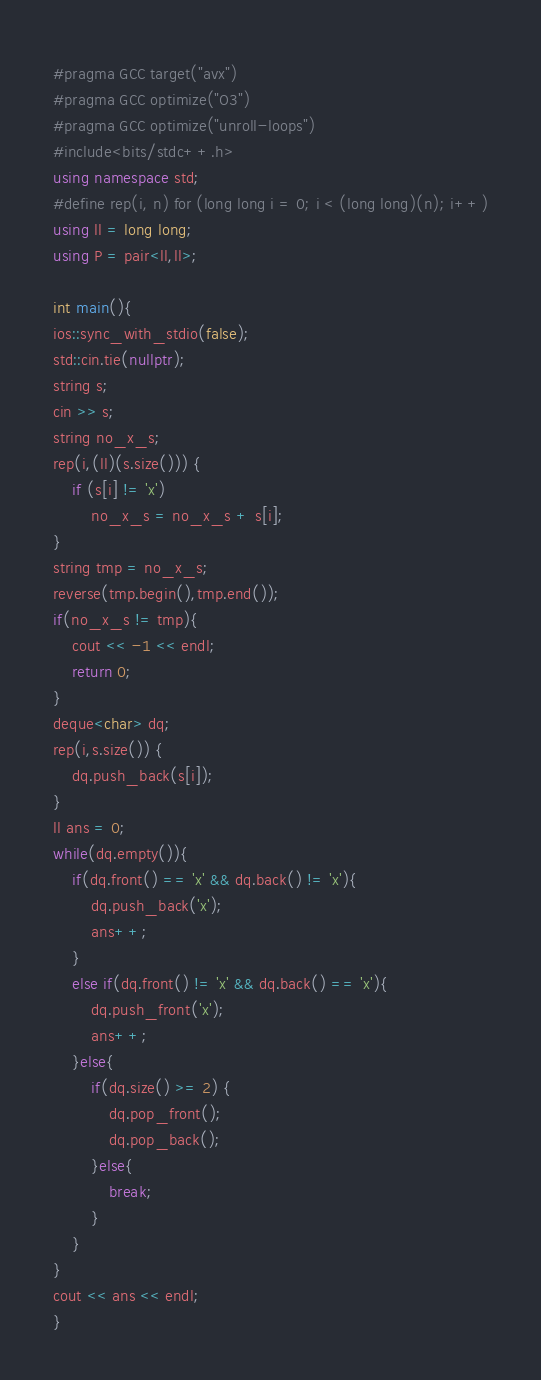<code> <loc_0><loc_0><loc_500><loc_500><_C++_>#pragma GCC target("avx")
#pragma GCC optimize("O3")
#pragma GCC optimize("unroll-loops")
#include<bits/stdc++.h>
using namespace std;
#define rep(i, n) for (long long i = 0; i < (long long)(n); i++)
using ll = long long;
using P = pair<ll,ll>;

int main(){
ios::sync_with_stdio(false);
std::cin.tie(nullptr);
string s;
cin >> s;
string no_x_s;
rep(i,(ll)(s.size())) {
    if (s[i] != 'x')
        no_x_s = no_x_s + s[i];
}
string tmp = no_x_s;
reverse(tmp.begin(),tmp.end());
if(no_x_s != tmp){
    cout << -1 << endl;
    return 0;
}
deque<char> dq;
rep(i,s.size()) {
    dq.push_back(s[i]);
}
ll ans = 0;
while(dq.empty()){
    if(dq.front() == 'x' && dq.back() != 'x'){
        dq.push_back('x');
        ans++;
    }
    else if(dq.front() != 'x' && dq.back() == 'x'){
        dq.push_front('x');
        ans++;
    }else{
        if(dq.size() >= 2) {
            dq.pop_front();
            dq.pop_back();
        }else{
            break;
        }
    }
}
cout << ans << endl;
}</code> 